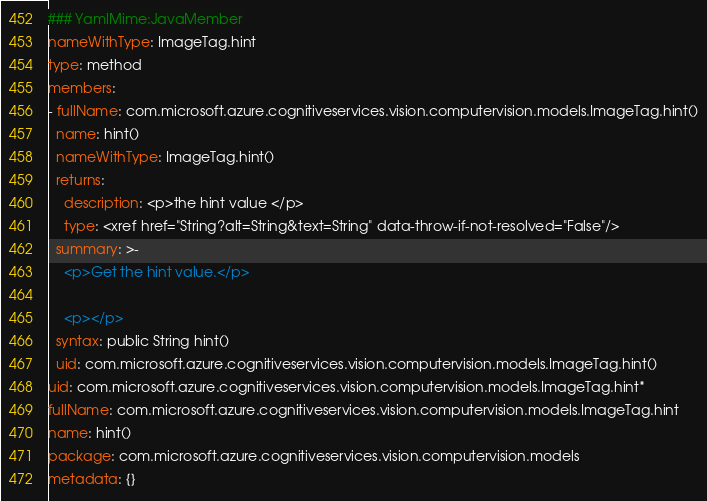Convert code to text. <code><loc_0><loc_0><loc_500><loc_500><_YAML_>### YamlMime:JavaMember
nameWithType: ImageTag.hint
type: method
members:
- fullName: com.microsoft.azure.cognitiveservices.vision.computervision.models.ImageTag.hint()
  name: hint()
  nameWithType: ImageTag.hint()
  returns:
    description: <p>the hint value </p>
    type: <xref href="String?alt=String&text=String" data-throw-if-not-resolved="False"/>
  summary: >-
    <p>Get the hint value.</p>

    <p></p>
  syntax: public String hint()
  uid: com.microsoft.azure.cognitiveservices.vision.computervision.models.ImageTag.hint()
uid: com.microsoft.azure.cognitiveservices.vision.computervision.models.ImageTag.hint*
fullName: com.microsoft.azure.cognitiveservices.vision.computervision.models.ImageTag.hint
name: hint()
package: com.microsoft.azure.cognitiveservices.vision.computervision.models
metadata: {}
</code> 